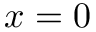<formula> <loc_0><loc_0><loc_500><loc_500>x = 0</formula> 